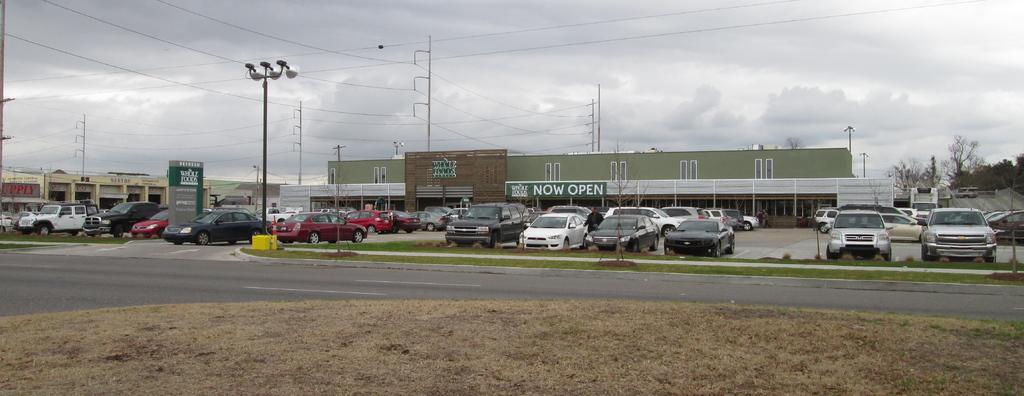<image>
Share a concise interpretation of the image provided. cars in a parking lot in front of a Whole Foods sign reading Now Open 